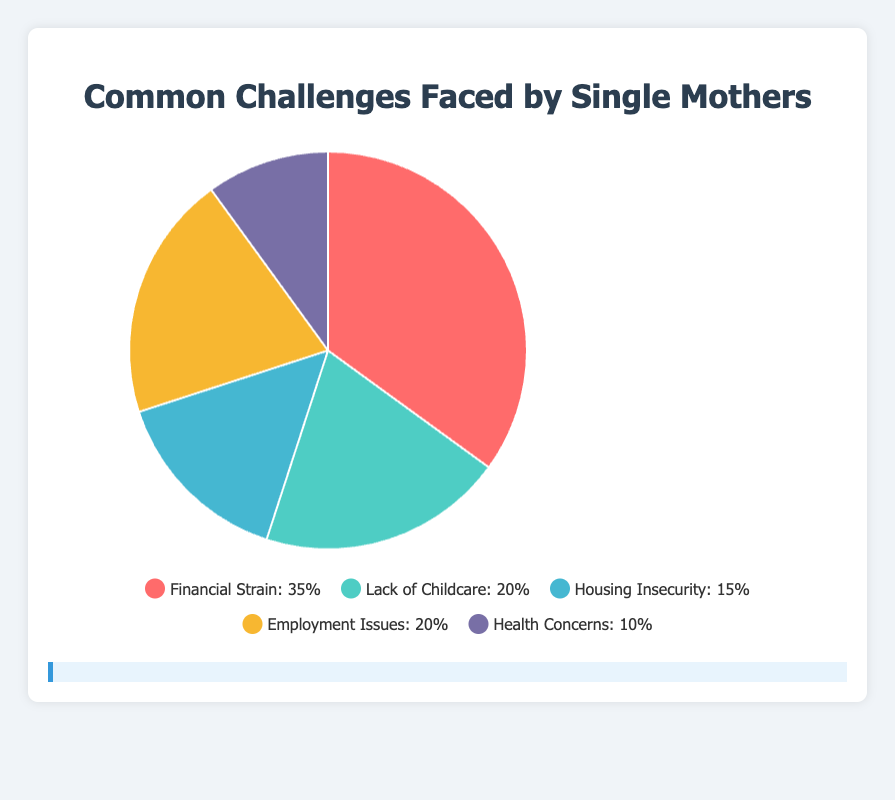Which challenge is most frequently reported by single mothers? The largest percentage slice in the pie chart represents the most frequently reported challenge. Here, 35% of single mothers report Financial Strain as their most common challenge.
Answer: Financial Strain What is the combined percentage of single mothers facing Lack of Childcare and Employment Issues? To find the combined percentage, add the percentages for Lack of Childcare (20%) and Employment Issues (20%). So, 20% + 20% = 40%.
Answer: 40% How does the percentage of single mothers experiencing Health Concerns compare with those facing Housing Insecurity? The pie chart shows that 10% of single mothers face Health Concerns while 15% face Housing Insecurity. 10% is less than 15%.
Answer: Health Concerns is less than Housing Insecurity What is the total percentage of challenges faced by single mothers other than Financial Strain? Subtract the percentage for Financial Strain (35%) from 100% to find the total percentage of other challenges: 100% - 35% = 65%.
Answer: 65% Which challenge category has the smallest percentage and what is that percentage? The smallest slice in the pie chart represents the smallest percentage. Here, Health Concerns have the smallest percentage at 10%.
Answer: Health Concerns, 10% What percentage of single mothers face either Employment Issues or Housing Insecurity? Add the percentages for Employment Issues (20%) and Housing Insecurity (15%). So, 20% + 15% = 35%.
Answer: 35% If we combine Financial Strain and Health Concerns, what would be their total percentage? Add the percentages for Financial Strain (35%) and Health Concerns (10%). So, 35% + 10% = 45%.
Answer: 45% Which color represents the Financial Strain challenge in the pie chart? Financial Strain, making up 35% of the pie chart, is colored red based on its color code.
Answer: Red 